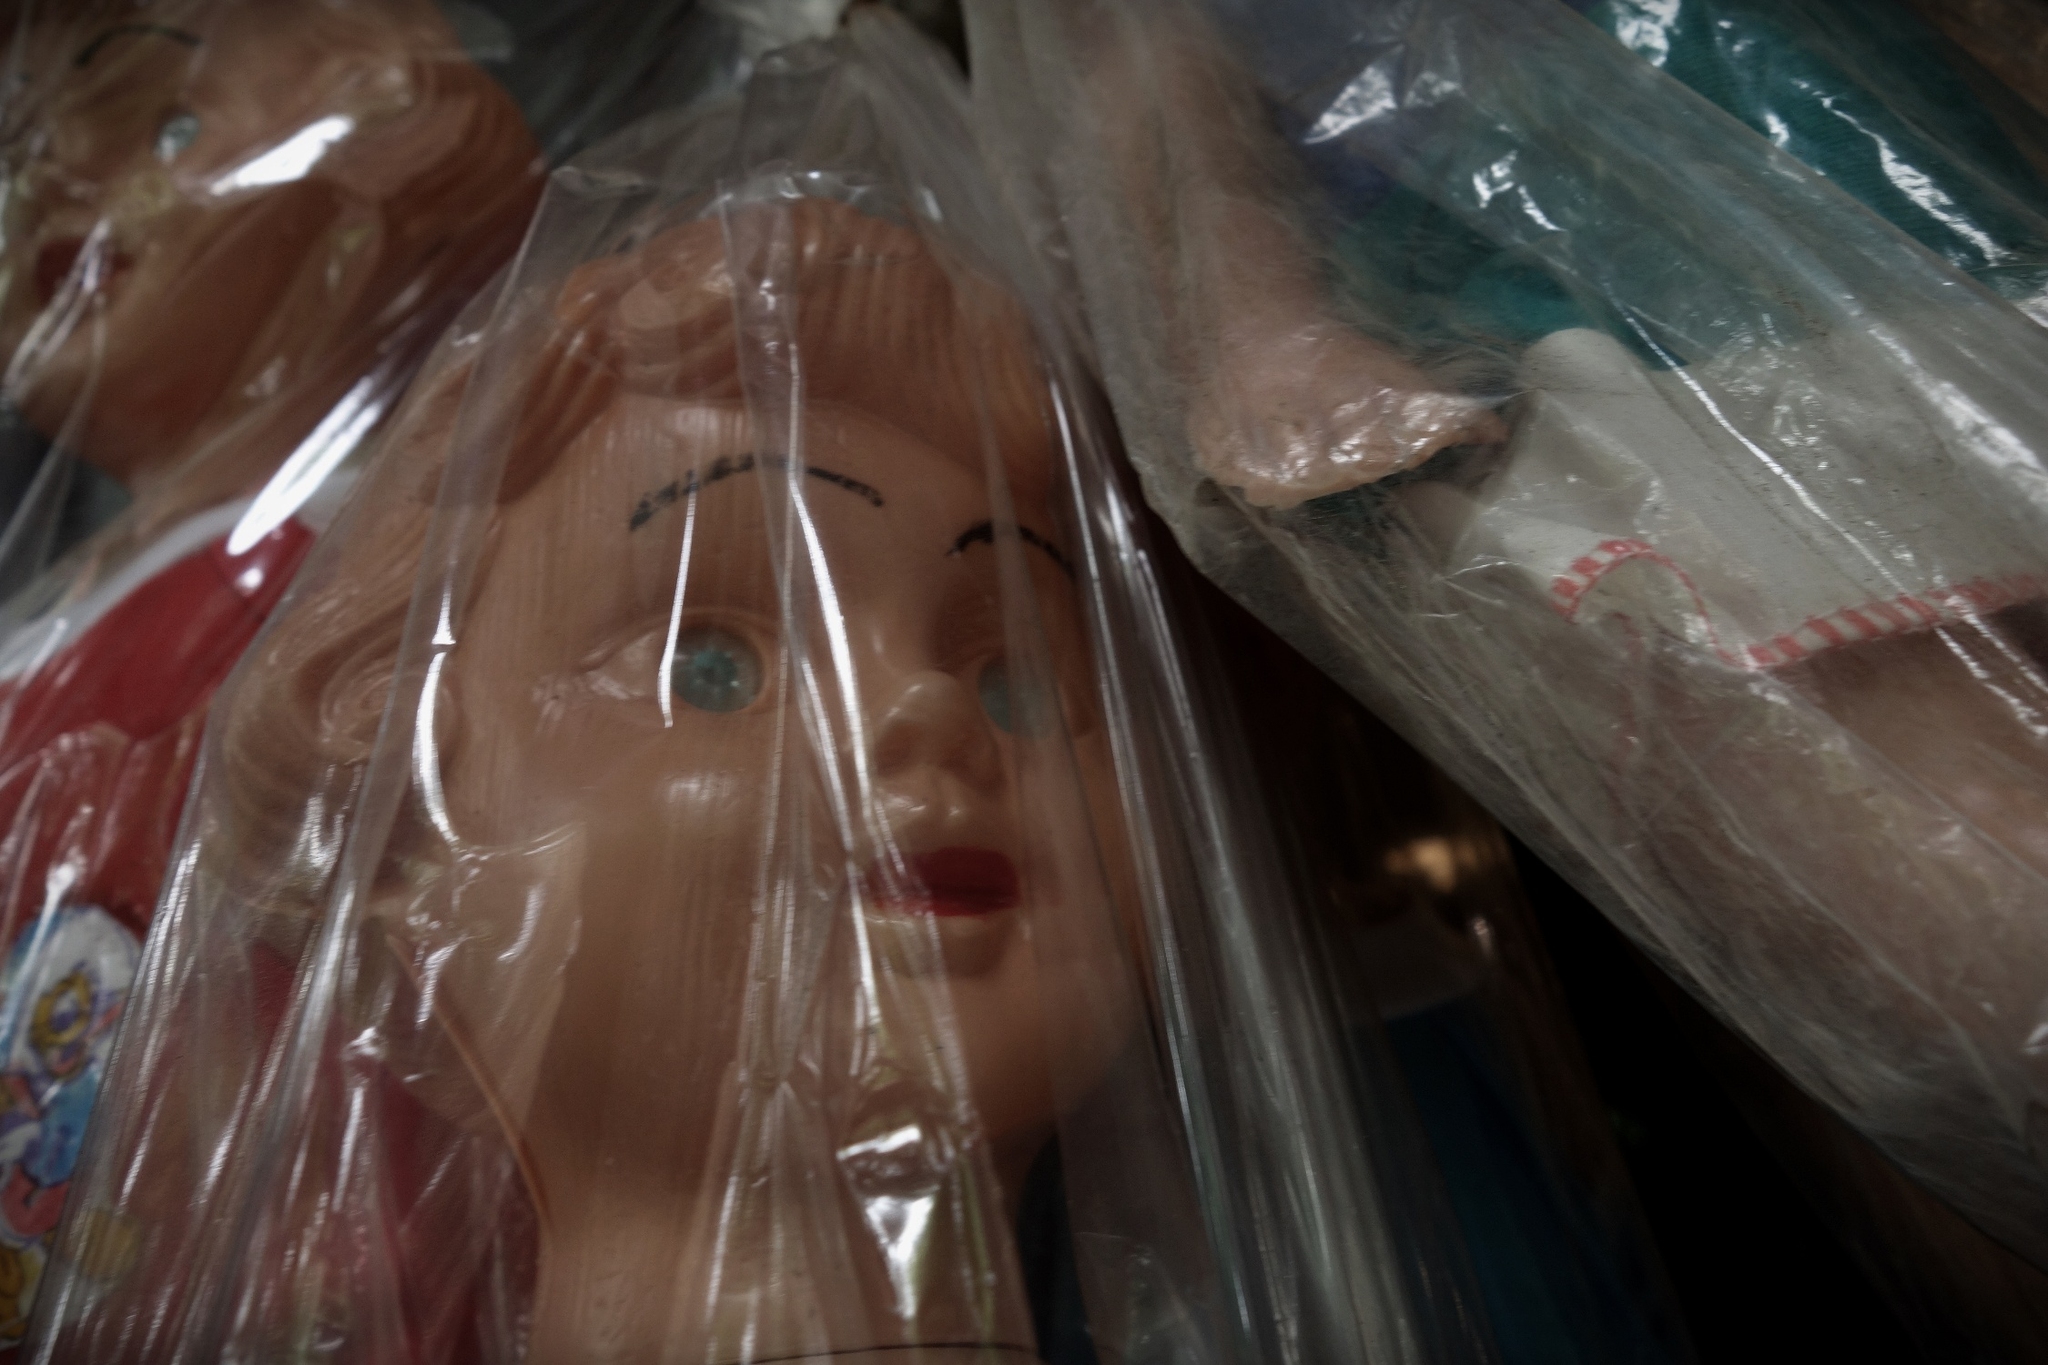What's happening in the scene? The image features a close-up view of a doll's face, encased in a clear plastic bag. The doll's most striking features are its bright blue eyes and pink lips, which draw immediate attention. Although partially obscured by the plastic bag, the doll's blonde hair is still somewhat visible. This particular doll is part of a larger collection—visible in the background are additional dolls, each also wrapped in plastic bags. These dolls come in a variety of styles and colors, suggesting a diverse and extensive collection. The composition of the photo places the primary doll in the foreground, making it the focal point, while the other dolls are slightly blurred in the background, creating a sense of depth. The objects are likely arranged for display or storage, as inferred from their positions and the clarity of the image. There is no text present, and the image offers no direct information regarding actions, given the inanimate nature of the dolls. Overall, the photograph provides a snapshot of a meticulously organized doll collection. 